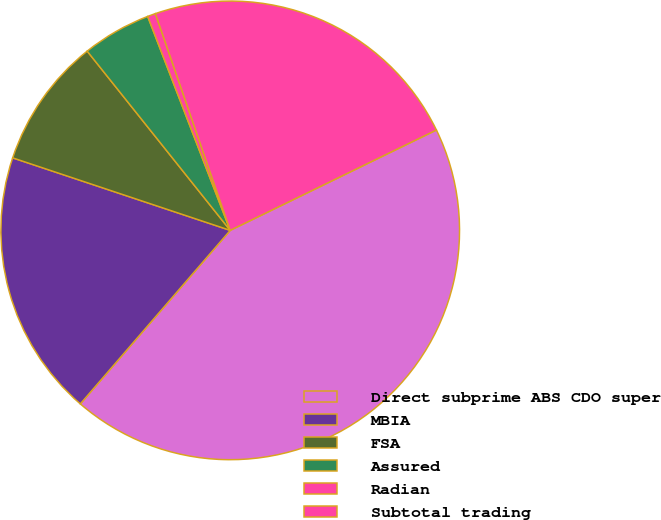Convert chart to OTSL. <chart><loc_0><loc_0><loc_500><loc_500><pie_chart><fcel>Direct subprime ABS CDO super<fcel>MBIA<fcel>FSA<fcel>Assured<fcel>Radian<fcel>Subtotal trading<nl><fcel>43.55%<fcel>18.78%<fcel>9.16%<fcel>4.86%<fcel>0.57%<fcel>23.08%<nl></chart> 